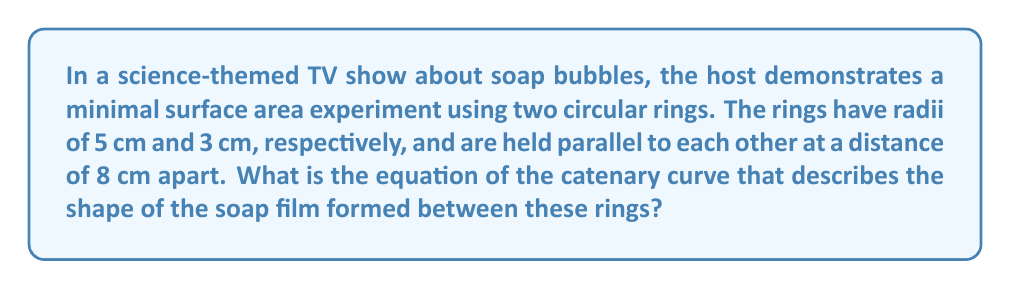Could you help me with this problem? To solve this problem, we'll follow these steps:

1) The minimal surface formed by a soap film between two circular rings is called a catenoid. Its shape is described by a catenary curve rotated around the axis connecting the centers of the rings.

2) The general equation of a catenary curve is:

   $$y = a \cosh(\frac{x}{a})$$

   where $a$ is a constant that determines the shape of the curve.

3) We need to find the value of $a$ that satisfies our boundary conditions. Let's set up our coordinate system so that the x-axis runs through the centers of both rings, with the origin halfway between them.

4) Our boundary conditions are:
   - At $x = -4$ cm, $y = 5$ cm (edge of the larger ring)
   - At $x = 4$ cm, $y = 3$ cm (edge of the smaller ring)

5) Applying these conditions to our equation:

   $$5 = a \cosh(\frac{-4}{a})$$
   $$3 = a \cosh(\frac{4}{a})$$

6) Due to the symmetry of the cosh function, these equations are equivalent. We can solve either one:

   $$5 = a \cosh(\frac{4}{a})$$

7) This equation can't be solved algebraically. We need to use numerical methods or a graphing calculator to find that $a \approx 3.417$ cm.

8) Therefore, the equation of the catenary curve describing the soap film is:

   $$y = 3.417 \cosh(\frac{x}{3.417})$$

Where $x$ and $y$ are in centimeters, and $x$ is measured from the midpoint between the rings.
Answer: $y = 3.417 \cosh(\frac{x}{3.417})$ 